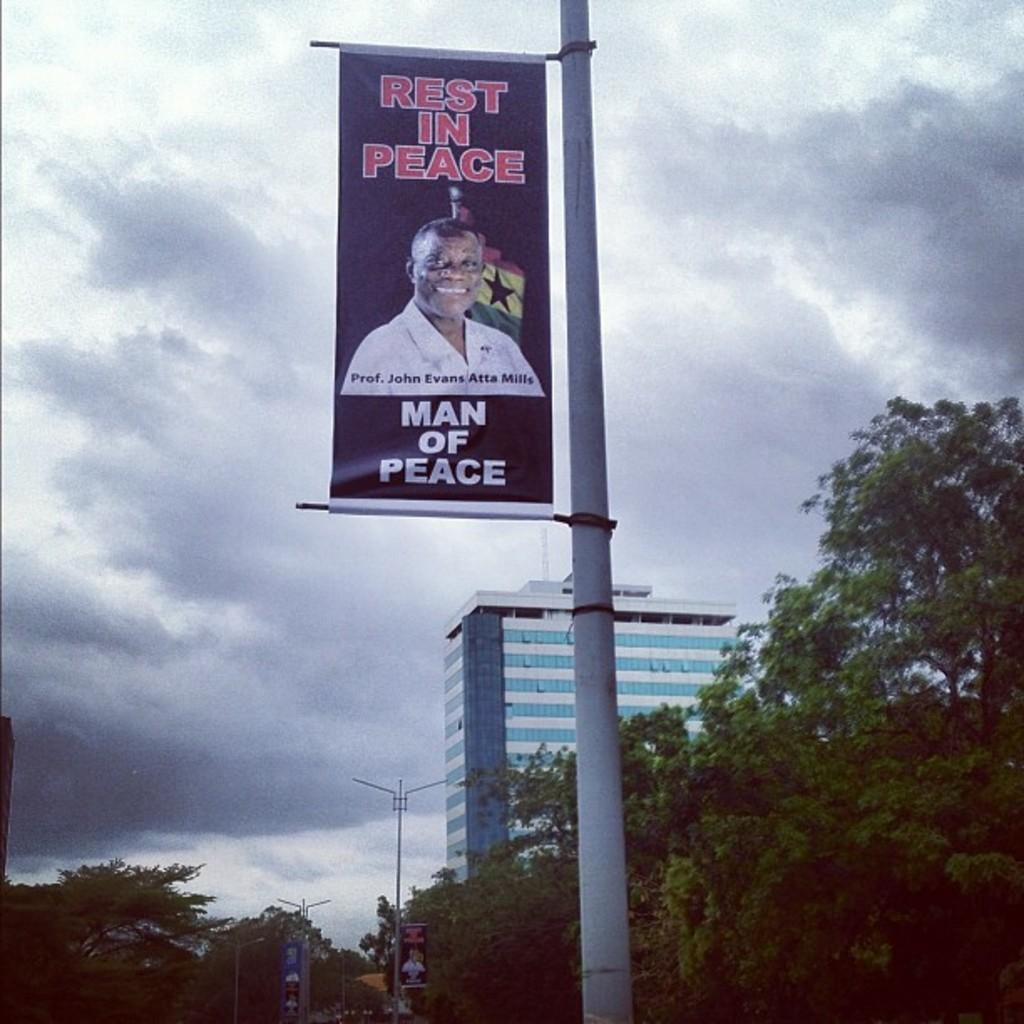<image>
Summarize the visual content of the image. A sign in memorial of John Evans Atta Mills, a man of peace. 